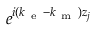Convert formula to latex. <formula><loc_0><loc_0><loc_500><loc_500>e ^ { i ( k _ { e } - k _ { m } ) z _ { j } }</formula> 